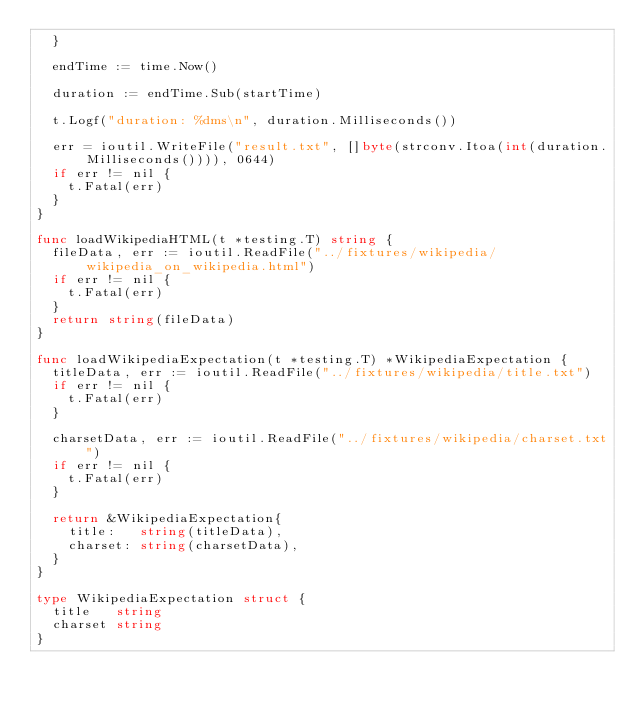Convert code to text. <code><loc_0><loc_0><loc_500><loc_500><_Go_>	}

	endTime := time.Now()

	duration := endTime.Sub(startTime)

	t.Logf("duration: %dms\n", duration.Milliseconds())

	err = ioutil.WriteFile("result.txt", []byte(strconv.Itoa(int(duration.Milliseconds()))), 0644)
	if err != nil {
		t.Fatal(err)
	}
}

func loadWikipediaHTML(t *testing.T) string {
	fileData, err := ioutil.ReadFile("../fixtures/wikipedia/wikipedia_on_wikipedia.html")
	if err != nil {
		t.Fatal(err)
	}
	return string(fileData)
}

func loadWikipediaExpectation(t *testing.T) *WikipediaExpectation {
	titleData, err := ioutil.ReadFile("../fixtures/wikipedia/title.txt")
	if err != nil {
		t.Fatal(err)
	}

	charsetData, err := ioutil.ReadFile("../fixtures/wikipedia/charset.txt")
	if err != nil {
		t.Fatal(err)
	}

	return &WikipediaExpectation{
		title:   string(titleData),
		charset: string(charsetData),
	}
}

type WikipediaExpectation struct {
	title   string
	charset string
}
</code> 